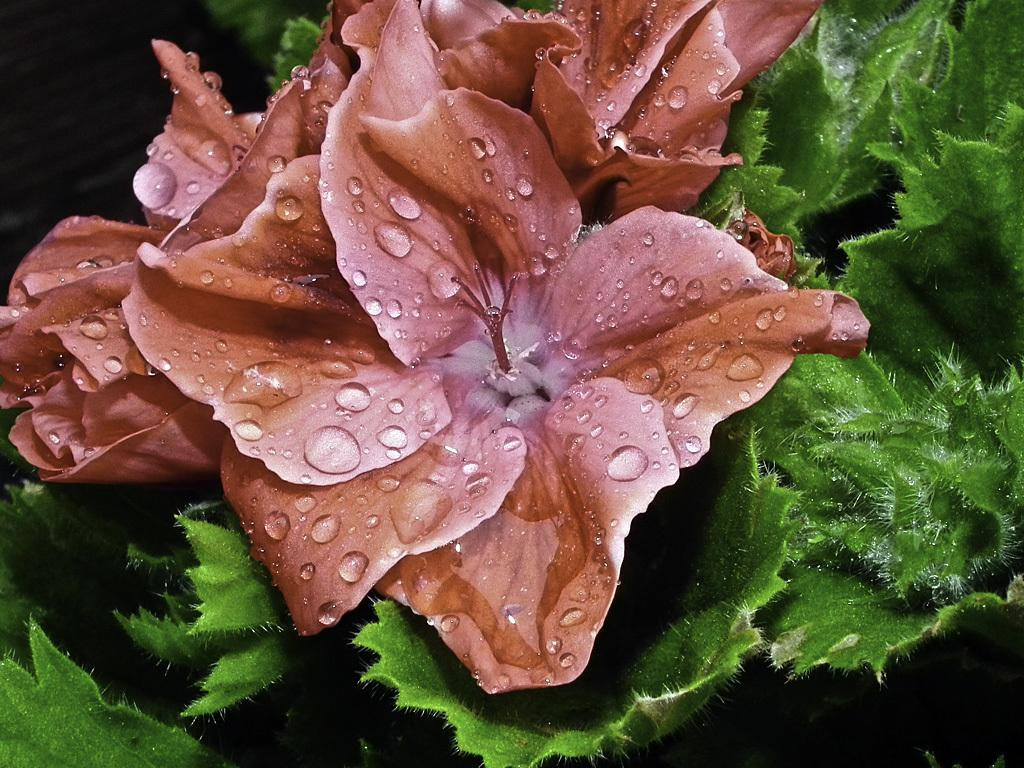What is the main subject of the image? The main subject of the image is a flower. How close is the focus on the flower in the image? The flower is the main focus of the image, which means it is zoomed in. What else can be seen in the background of the image? There are leaves in the background of the image. What type of thread is being used to create the flower's balance in the image? There is no thread or balance mentioned in the image; it simply features a flower with leaves in the background. 